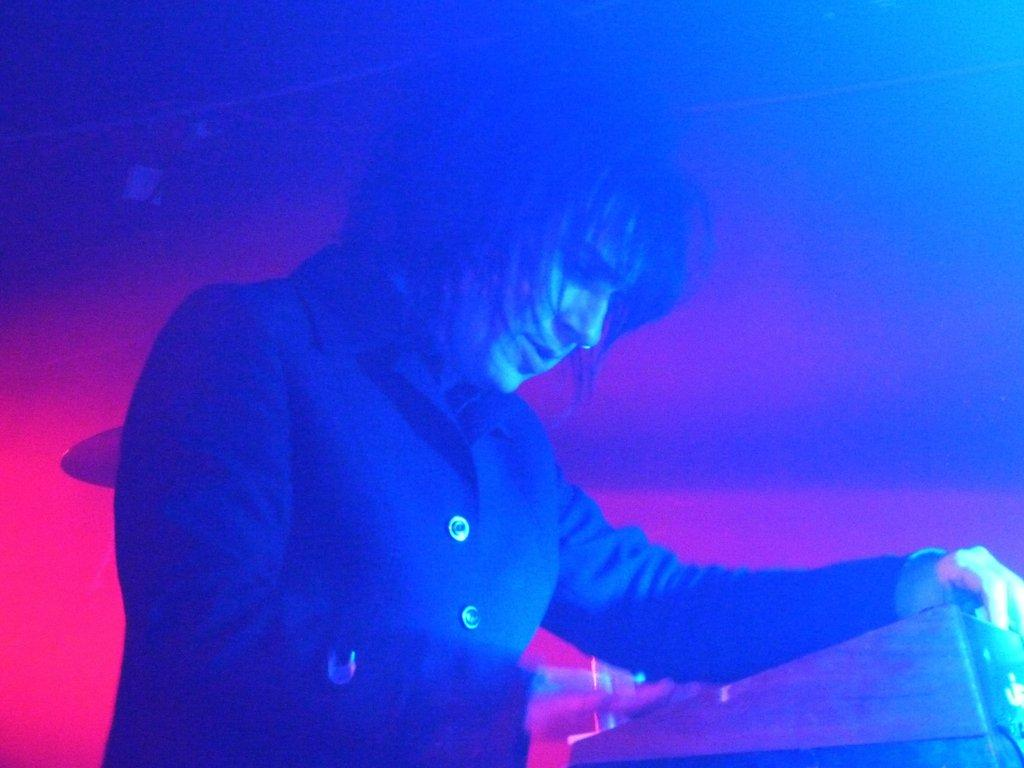What is the person in the image doing? The person is standing in front of a table. What can be seen near the person? There are musical instruments beside the person. Where is the sofa located in the image? There is no sofa present in the image. What force is being applied by the person to the musical instruments? The image does not provide information about any force being applied by the person to the musical instruments. 